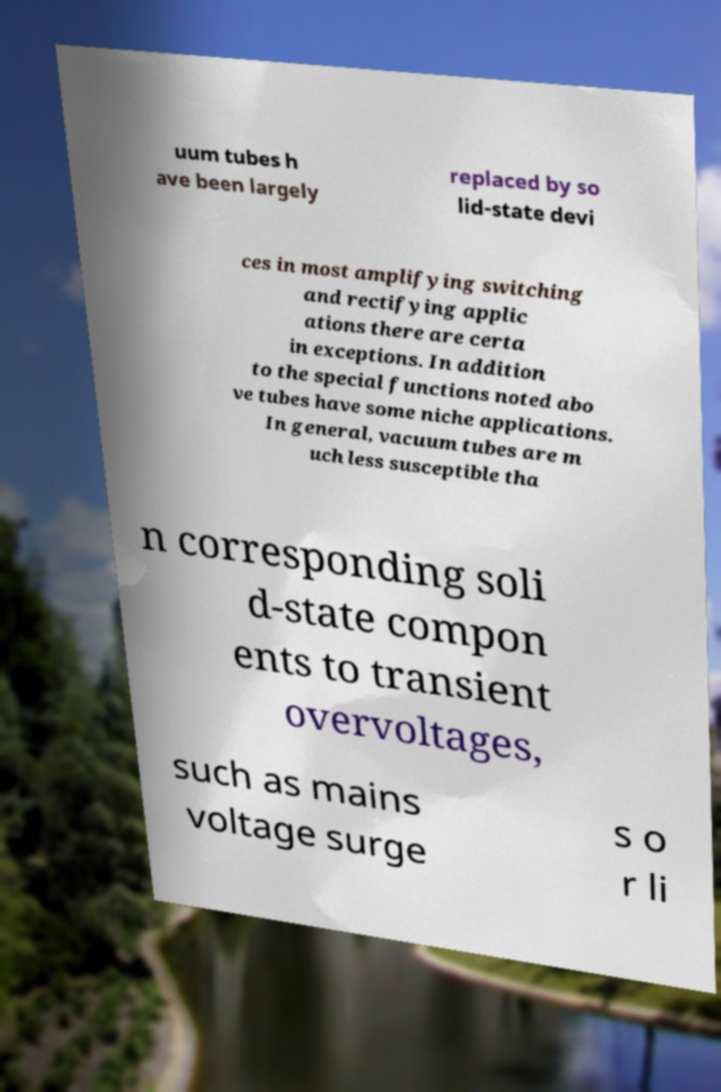Can you accurately transcribe the text from the provided image for me? uum tubes h ave been largely replaced by so lid-state devi ces in most amplifying switching and rectifying applic ations there are certa in exceptions. In addition to the special functions noted abo ve tubes have some niche applications. In general, vacuum tubes are m uch less susceptible tha n corresponding soli d-state compon ents to transient overvoltages, such as mains voltage surge s o r li 